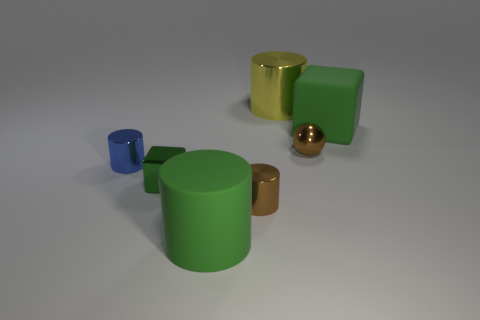Add 3 green blocks. How many objects exist? 10 Subtract all blocks. How many objects are left? 5 Add 7 green rubber cylinders. How many green rubber cylinders are left? 8 Add 1 brown objects. How many brown objects exist? 3 Subtract 1 yellow cylinders. How many objects are left? 6 Subtract all red metallic cylinders. Subtract all spheres. How many objects are left? 6 